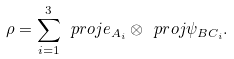Convert formula to latex. <formula><loc_0><loc_0><loc_500><loc_500>\rho = \sum _ { i = 1 } ^ { 3 } \ p r o j { e _ { A _ { i } } } \otimes \ p r o j { \psi _ { B C _ { i } } } .</formula> 